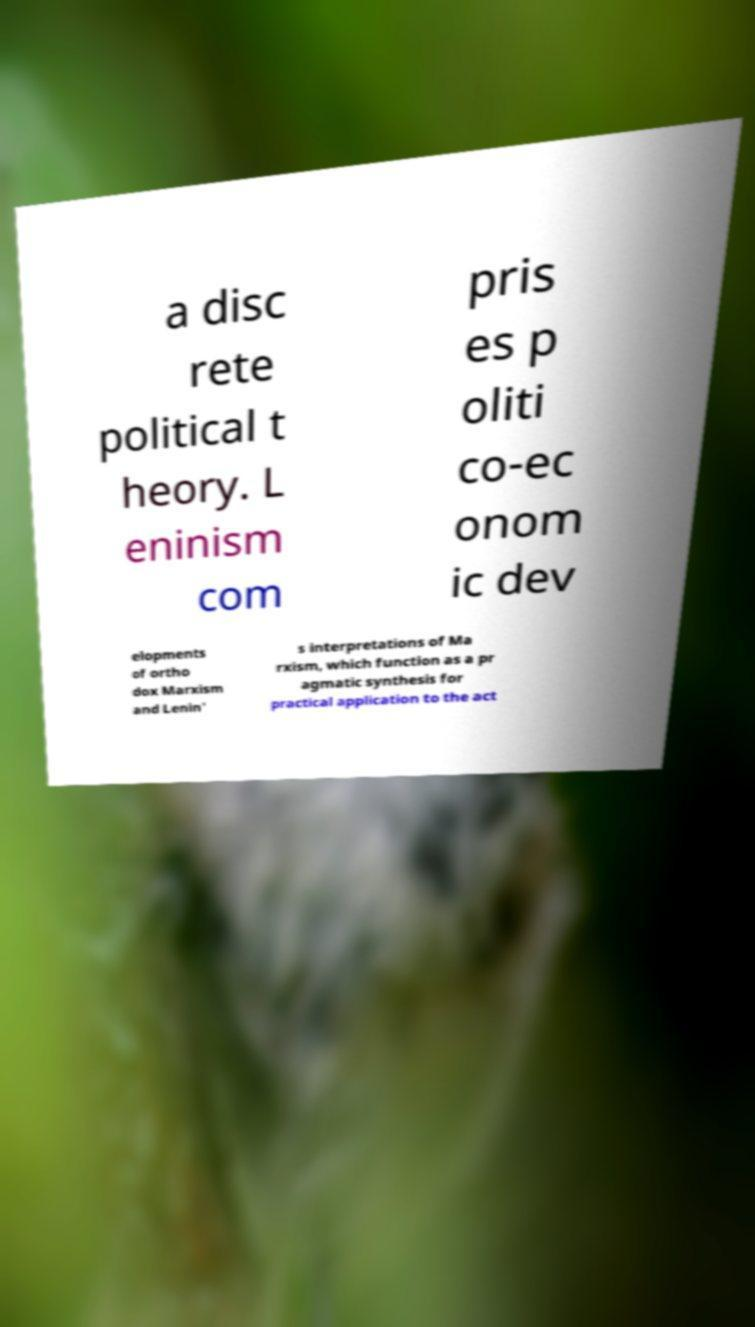There's text embedded in this image that I need extracted. Can you transcribe it verbatim? a disc rete political t heory. L eninism com pris es p oliti co-ec onom ic dev elopments of ortho dox Marxism and Lenin' s interpretations of Ma rxism, which function as a pr agmatic synthesis for practical application to the act 